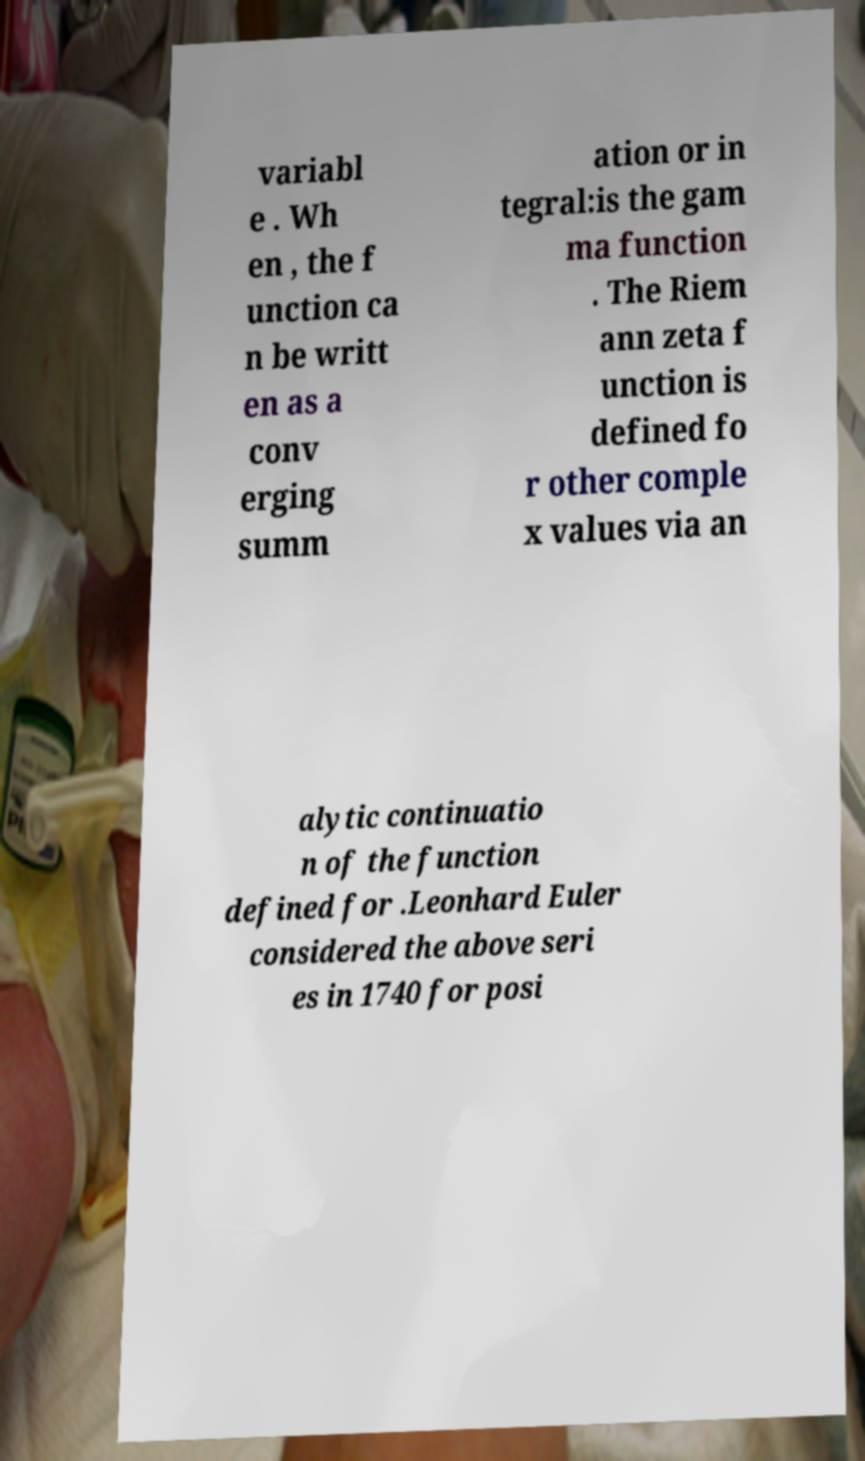Can you accurately transcribe the text from the provided image for me? variabl e . Wh en , the f unction ca n be writt en as a conv erging summ ation or in tegral:is the gam ma function . The Riem ann zeta f unction is defined fo r other comple x values via an alytic continuatio n of the function defined for .Leonhard Euler considered the above seri es in 1740 for posi 